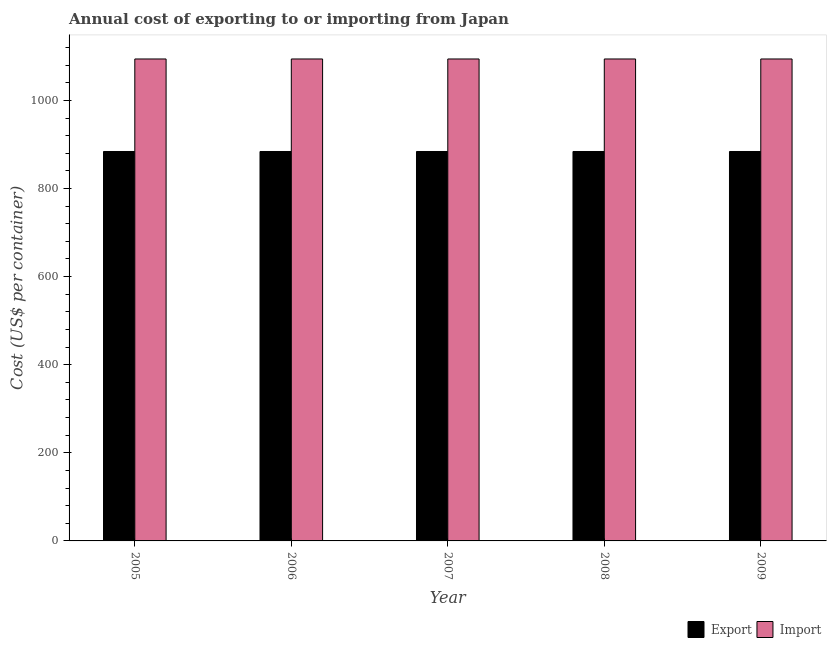How many different coloured bars are there?
Ensure brevity in your answer.  2. Are the number of bars per tick equal to the number of legend labels?
Your answer should be very brief. Yes. How many bars are there on the 3rd tick from the left?
Make the answer very short. 2. How many bars are there on the 1st tick from the right?
Your response must be concise. 2. What is the label of the 5th group of bars from the left?
Offer a terse response. 2009. What is the export cost in 2008?
Provide a short and direct response. 884. Across all years, what is the maximum import cost?
Offer a terse response. 1094. Across all years, what is the minimum export cost?
Keep it short and to the point. 884. In which year was the export cost minimum?
Offer a terse response. 2005. What is the total import cost in the graph?
Make the answer very short. 5470. What is the difference between the import cost in 2007 and the export cost in 2009?
Provide a succinct answer. 0. What is the average import cost per year?
Your answer should be compact. 1094. In the year 2007, what is the difference between the export cost and import cost?
Provide a succinct answer. 0. What is the difference between the highest and the second highest import cost?
Give a very brief answer. 0. What is the difference between the highest and the lowest export cost?
Offer a terse response. 0. In how many years, is the export cost greater than the average export cost taken over all years?
Provide a short and direct response. 0. What does the 2nd bar from the left in 2009 represents?
Your answer should be compact. Import. What does the 2nd bar from the right in 2009 represents?
Keep it short and to the point. Export. Are all the bars in the graph horizontal?
Your answer should be compact. No. Does the graph contain grids?
Your response must be concise. No. How many legend labels are there?
Make the answer very short. 2. What is the title of the graph?
Provide a succinct answer. Annual cost of exporting to or importing from Japan. Does "Technicians" appear as one of the legend labels in the graph?
Ensure brevity in your answer.  No. What is the label or title of the Y-axis?
Keep it short and to the point. Cost (US$ per container). What is the Cost (US$ per container) of Export in 2005?
Your response must be concise. 884. What is the Cost (US$ per container) in Import in 2005?
Provide a short and direct response. 1094. What is the Cost (US$ per container) of Export in 2006?
Make the answer very short. 884. What is the Cost (US$ per container) in Import in 2006?
Offer a terse response. 1094. What is the Cost (US$ per container) of Export in 2007?
Offer a very short reply. 884. What is the Cost (US$ per container) of Import in 2007?
Make the answer very short. 1094. What is the Cost (US$ per container) of Export in 2008?
Provide a short and direct response. 884. What is the Cost (US$ per container) of Import in 2008?
Keep it short and to the point. 1094. What is the Cost (US$ per container) in Export in 2009?
Your answer should be very brief. 884. What is the Cost (US$ per container) of Import in 2009?
Offer a very short reply. 1094. Across all years, what is the maximum Cost (US$ per container) of Export?
Provide a succinct answer. 884. Across all years, what is the maximum Cost (US$ per container) in Import?
Provide a succinct answer. 1094. Across all years, what is the minimum Cost (US$ per container) of Export?
Your answer should be compact. 884. Across all years, what is the minimum Cost (US$ per container) of Import?
Provide a short and direct response. 1094. What is the total Cost (US$ per container) of Export in the graph?
Make the answer very short. 4420. What is the total Cost (US$ per container) of Import in the graph?
Offer a terse response. 5470. What is the difference between the Cost (US$ per container) in Export in 2005 and that in 2006?
Ensure brevity in your answer.  0. What is the difference between the Cost (US$ per container) of Export in 2005 and that in 2007?
Provide a short and direct response. 0. What is the difference between the Cost (US$ per container) in Import in 2005 and that in 2008?
Your answer should be compact. 0. What is the difference between the Cost (US$ per container) of Export in 2005 and that in 2009?
Your answer should be very brief. 0. What is the difference between the Cost (US$ per container) of Import in 2005 and that in 2009?
Make the answer very short. 0. What is the difference between the Cost (US$ per container) in Import in 2006 and that in 2008?
Your answer should be very brief. 0. What is the difference between the Cost (US$ per container) of Export in 2006 and that in 2009?
Offer a very short reply. 0. What is the difference between the Cost (US$ per container) in Export in 2007 and that in 2008?
Your answer should be very brief. 0. What is the difference between the Cost (US$ per container) of Import in 2007 and that in 2008?
Provide a short and direct response. 0. What is the difference between the Cost (US$ per container) in Export in 2007 and that in 2009?
Keep it short and to the point. 0. What is the difference between the Cost (US$ per container) in Export in 2008 and that in 2009?
Offer a terse response. 0. What is the difference between the Cost (US$ per container) in Import in 2008 and that in 2009?
Provide a short and direct response. 0. What is the difference between the Cost (US$ per container) of Export in 2005 and the Cost (US$ per container) of Import in 2006?
Provide a short and direct response. -210. What is the difference between the Cost (US$ per container) of Export in 2005 and the Cost (US$ per container) of Import in 2007?
Offer a very short reply. -210. What is the difference between the Cost (US$ per container) in Export in 2005 and the Cost (US$ per container) in Import in 2008?
Offer a terse response. -210. What is the difference between the Cost (US$ per container) of Export in 2005 and the Cost (US$ per container) of Import in 2009?
Your response must be concise. -210. What is the difference between the Cost (US$ per container) of Export in 2006 and the Cost (US$ per container) of Import in 2007?
Offer a terse response. -210. What is the difference between the Cost (US$ per container) in Export in 2006 and the Cost (US$ per container) in Import in 2008?
Provide a short and direct response. -210. What is the difference between the Cost (US$ per container) of Export in 2006 and the Cost (US$ per container) of Import in 2009?
Give a very brief answer. -210. What is the difference between the Cost (US$ per container) in Export in 2007 and the Cost (US$ per container) in Import in 2008?
Provide a succinct answer. -210. What is the difference between the Cost (US$ per container) in Export in 2007 and the Cost (US$ per container) in Import in 2009?
Provide a short and direct response. -210. What is the difference between the Cost (US$ per container) in Export in 2008 and the Cost (US$ per container) in Import in 2009?
Keep it short and to the point. -210. What is the average Cost (US$ per container) of Export per year?
Your answer should be very brief. 884. What is the average Cost (US$ per container) in Import per year?
Provide a succinct answer. 1094. In the year 2005, what is the difference between the Cost (US$ per container) in Export and Cost (US$ per container) in Import?
Give a very brief answer. -210. In the year 2006, what is the difference between the Cost (US$ per container) of Export and Cost (US$ per container) of Import?
Provide a short and direct response. -210. In the year 2007, what is the difference between the Cost (US$ per container) of Export and Cost (US$ per container) of Import?
Your response must be concise. -210. In the year 2008, what is the difference between the Cost (US$ per container) in Export and Cost (US$ per container) in Import?
Your answer should be very brief. -210. In the year 2009, what is the difference between the Cost (US$ per container) in Export and Cost (US$ per container) in Import?
Your response must be concise. -210. What is the ratio of the Cost (US$ per container) in Export in 2005 to that in 2006?
Provide a succinct answer. 1. What is the ratio of the Cost (US$ per container) in Import in 2005 to that in 2006?
Make the answer very short. 1. What is the ratio of the Cost (US$ per container) of Export in 2005 to that in 2007?
Your answer should be compact. 1. What is the ratio of the Cost (US$ per container) of Import in 2005 to that in 2007?
Your response must be concise. 1. What is the ratio of the Cost (US$ per container) in Import in 2005 to that in 2008?
Offer a terse response. 1. What is the ratio of the Cost (US$ per container) in Export in 2005 to that in 2009?
Offer a terse response. 1. What is the ratio of the Cost (US$ per container) in Export in 2006 to that in 2008?
Offer a very short reply. 1. What is the ratio of the Cost (US$ per container) in Import in 2006 to that in 2008?
Keep it short and to the point. 1. What is the ratio of the Cost (US$ per container) of Export in 2006 to that in 2009?
Your response must be concise. 1. What is the ratio of the Cost (US$ per container) in Import in 2006 to that in 2009?
Your response must be concise. 1. What is the ratio of the Cost (US$ per container) in Export in 2007 to that in 2008?
Provide a succinct answer. 1. What is the ratio of the Cost (US$ per container) in Export in 2007 to that in 2009?
Ensure brevity in your answer.  1. What is the ratio of the Cost (US$ per container) of Export in 2008 to that in 2009?
Keep it short and to the point. 1. What is the difference between the highest and the second highest Cost (US$ per container) of Export?
Offer a terse response. 0. What is the difference between the highest and the second highest Cost (US$ per container) in Import?
Ensure brevity in your answer.  0. What is the difference between the highest and the lowest Cost (US$ per container) of Export?
Give a very brief answer. 0. 